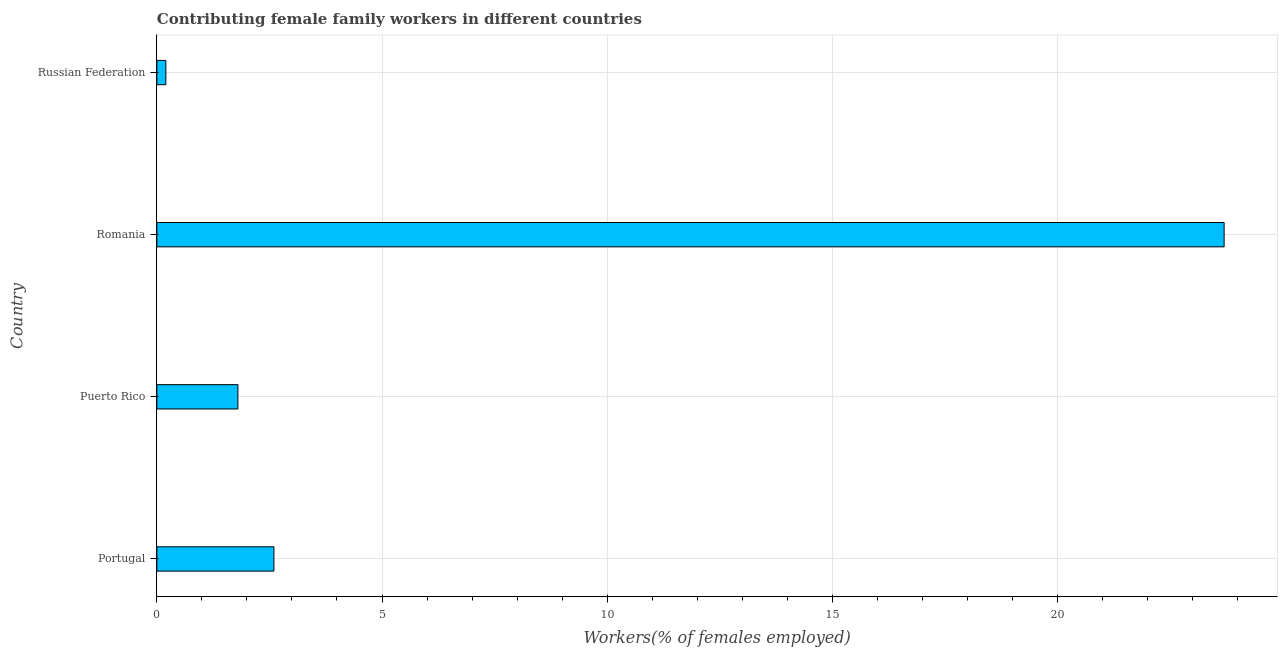What is the title of the graph?
Offer a terse response. Contributing female family workers in different countries. What is the label or title of the X-axis?
Provide a short and direct response. Workers(% of females employed). What is the label or title of the Y-axis?
Ensure brevity in your answer.  Country. What is the contributing female family workers in Romania?
Keep it short and to the point. 23.7. Across all countries, what is the maximum contributing female family workers?
Your answer should be very brief. 23.7. Across all countries, what is the minimum contributing female family workers?
Ensure brevity in your answer.  0.2. In which country was the contributing female family workers maximum?
Ensure brevity in your answer.  Romania. In which country was the contributing female family workers minimum?
Offer a very short reply. Russian Federation. What is the sum of the contributing female family workers?
Offer a terse response. 28.3. What is the average contributing female family workers per country?
Your response must be concise. 7.08. What is the median contributing female family workers?
Ensure brevity in your answer.  2.2. What is the ratio of the contributing female family workers in Puerto Rico to that in Romania?
Make the answer very short. 0.08. Is the contributing female family workers in Puerto Rico less than that in Romania?
Your response must be concise. Yes. What is the difference between the highest and the second highest contributing female family workers?
Ensure brevity in your answer.  21.1. Is the sum of the contributing female family workers in Portugal and Puerto Rico greater than the maximum contributing female family workers across all countries?
Keep it short and to the point. No. What is the difference between the highest and the lowest contributing female family workers?
Ensure brevity in your answer.  23.5. In how many countries, is the contributing female family workers greater than the average contributing female family workers taken over all countries?
Offer a very short reply. 1. Are all the bars in the graph horizontal?
Your answer should be compact. Yes. What is the difference between two consecutive major ticks on the X-axis?
Your response must be concise. 5. Are the values on the major ticks of X-axis written in scientific E-notation?
Your response must be concise. No. What is the Workers(% of females employed) in Portugal?
Make the answer very short. 2.6. What is the Workers(% of females employed) in Puerto Rico?
Give a very brief answer. 1.8. What is the Workers(% of females employed) of Romania?
Your answer should be compact. 23.7. What is the Workers(% of females employed) of Russian Federation?
Your answer should be compact. 0.2. What is the difference between the Workers(% of females employed) in Portugal and Romania?
Offer a terse response. -21.1. What is the difference between the Workers(% of females employed) in Puerto Rico and Romania?
Make the answer very short. -21.9. What is the difference between the Workers(% of females employed) in Puerto Rico and Russian Federation?
Offer a terse response. 1.6. What is the difference between the Workers(% of females employed) in Romania and Russian Federation?
Offer a very short reply. 23.5. What is the ratio of the Workers(% of females employed) in Portugal to that in Puerto Rico?
Your answer should be compact. 1.44. What is the ratio of the Workers(% of females employed) in Portugal to that in Romania?
Ensure brevity in your answer.  0.11. What is the ratio of the Workers(% of females employed) in Puerto Rico to that in Romania?
Ensure brevity in your answer.  0.08. What is the ratio of the Workers(% of females employed) in Romania to that in Russian Federation?
Your answer should be very brief. 118.5. 